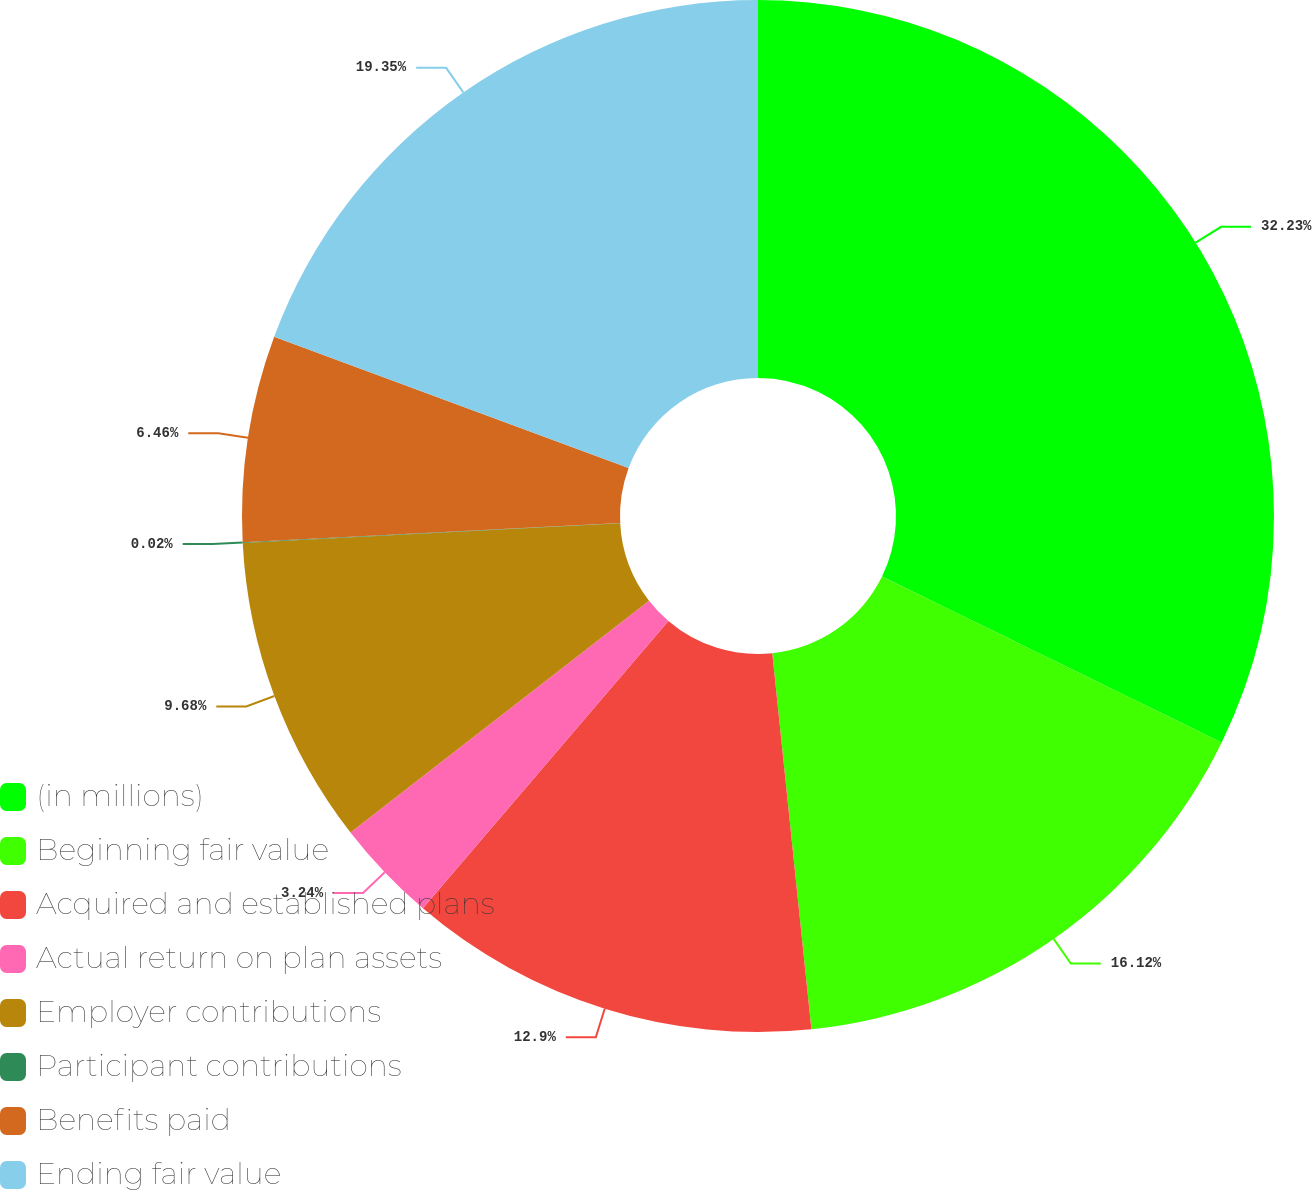<chart> <loc_0><loc_0><loc_500><loc_500><pie_chart><fcel>(in millions)<fcel>Beginning fair value<fcel>Acquired and established plans<fcel>Actual return on plan assets<fcel>Employer contributions<fcel>Participant contributions<fcel>Benefits paid<fcel>Ending fair value<nl><fcel>32.23%<fcel>16.12%<fcel>12.9%<fcel>3.24%<fcel>9.68%<fcel>0.02%<fcel>6.46%<fcel>19.35%<nl></chart> 